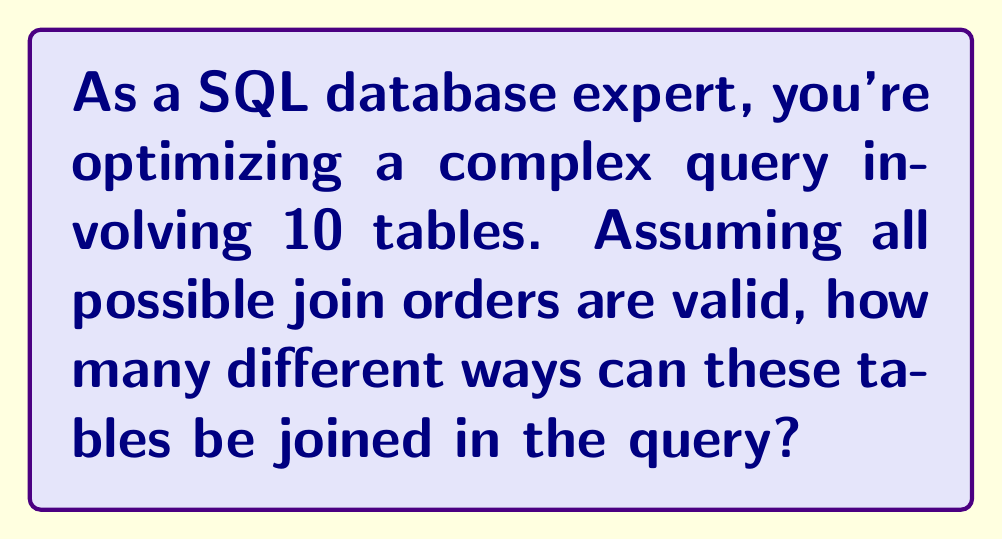Could you help me with this problem? To solve this problem, we need to understand that the number of possible join orders for n tables is equivalent to the number of permutations of n elements. This is because each join order represents a unique arrangement of the tables.

The number of permutations of n distinct elements is given by the factorial of n, denoted as n!

For our case, we have 10 tables, so n = 10.

The formula for the number of possible join orders is:

$$10! = 10 \times 9 \times 8 \times 7 \times 6 \times 5 \times 4 \times 3 \times 2 \times 1$$

Let's calculate this step by step:

1) $10 \times 9 = 90$
2) $90 \times 8 = 720$
3) $720 \times 7 = 5,040$
4) $5,040 \times 6 = 30,240$
5) $30,240 \times 5 = 151,200$
6) $151,200 \times 4 = 604,800$
7) $604,800 \times 3 = 1,814,400$
8) $1,814,400 \times 2 = 3,628,800$
9) $3,628,800 \times 1 = 3,628,800$

Therefore, the total number of possible join orders for 10 tables is 3,628,800.

This large number emphasizes the importance of query optimization in SQL, as the order of joins can significantly impact query performance.
Answer: $3,628,800$ 